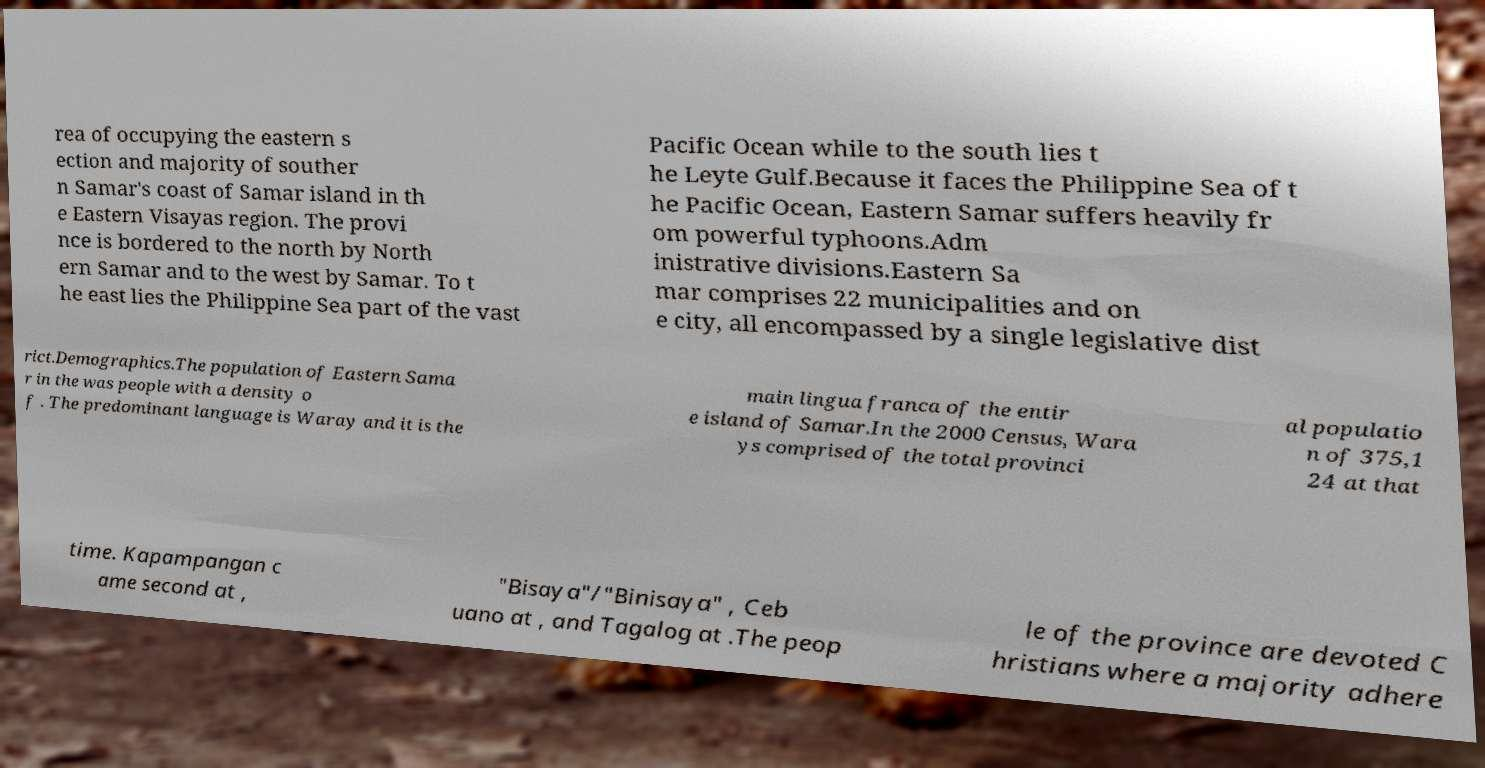There's text embedded in this image that I need extracted. Can you transcribe it verbatim? rea of occupying the eastern s ection and majority of souther n Samar's coast of Samar island in th e Eastern Visayas region. The provi nce is bordered to the north by North ern Samar and to the west by Samar. To t he east lies the Philippine Sea part of the vast Pacific Ocean while to the south lies t he Leyte Gulf.Because it faces the Philippine Sea of t he Pacific Ocean, Eastern Samar suffers heavily fr om powerful typhoons.Adm inistrative divisions.Eastern Sa mar comprises 22 municipalities and on e city, all encompassed by a single legislative dist rict.Demographics.The population of Eastern Sama r in the was people with a density o f . The predominant language is Waray and it is the main lingua franca of the entir e island of Samar.In the 2000 Census, Wara ys comprised of the total provinci al populatio n of 375,1 24 at that time. Kapampangan c ame second at , "Bisaya"/"Binisaya" , Ceb uano at , and Tagalog at .The peop le of the province are devoted C hristians where a majority adhere 